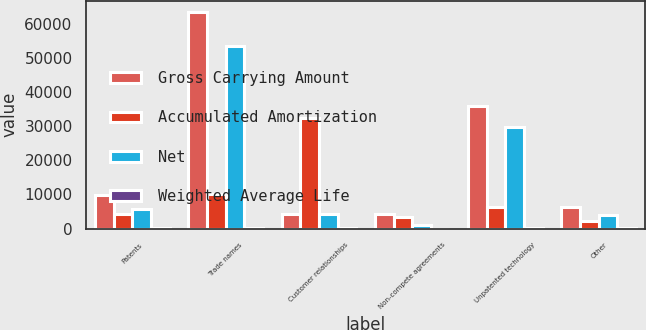Convert chart. <chart><loc_0><loc_0><loc_500><loc_500><stacked_bar_chart><ecel><fcel>Patents<fcel>Trade names<fcel>Customer relationships<fcel>Non-compete agreements<fcel>Unpatented technology<fcel>Other<nl><fcel>Gross Carrying Amount<fcel>9914<fcel>63589<fcel>4278.5<fcel>4268<fcel>36047<fcel>6236<nl><fcel>Accumulated Amortization<fcel>4289<fcel>10144<fcel>32422<fcel>3356<fcel>6240<fcel>2239<nl><fcel>Net<fcel>5625<fcel>53445<fcel>4278.5<fcel>912<fcel>29807<fcel>3997<nl><fcel>Weighted Average Life<fcel>11<fcel>15<fcel>12<fcel>4<fcel>14<fcel>10<nl></chart> 